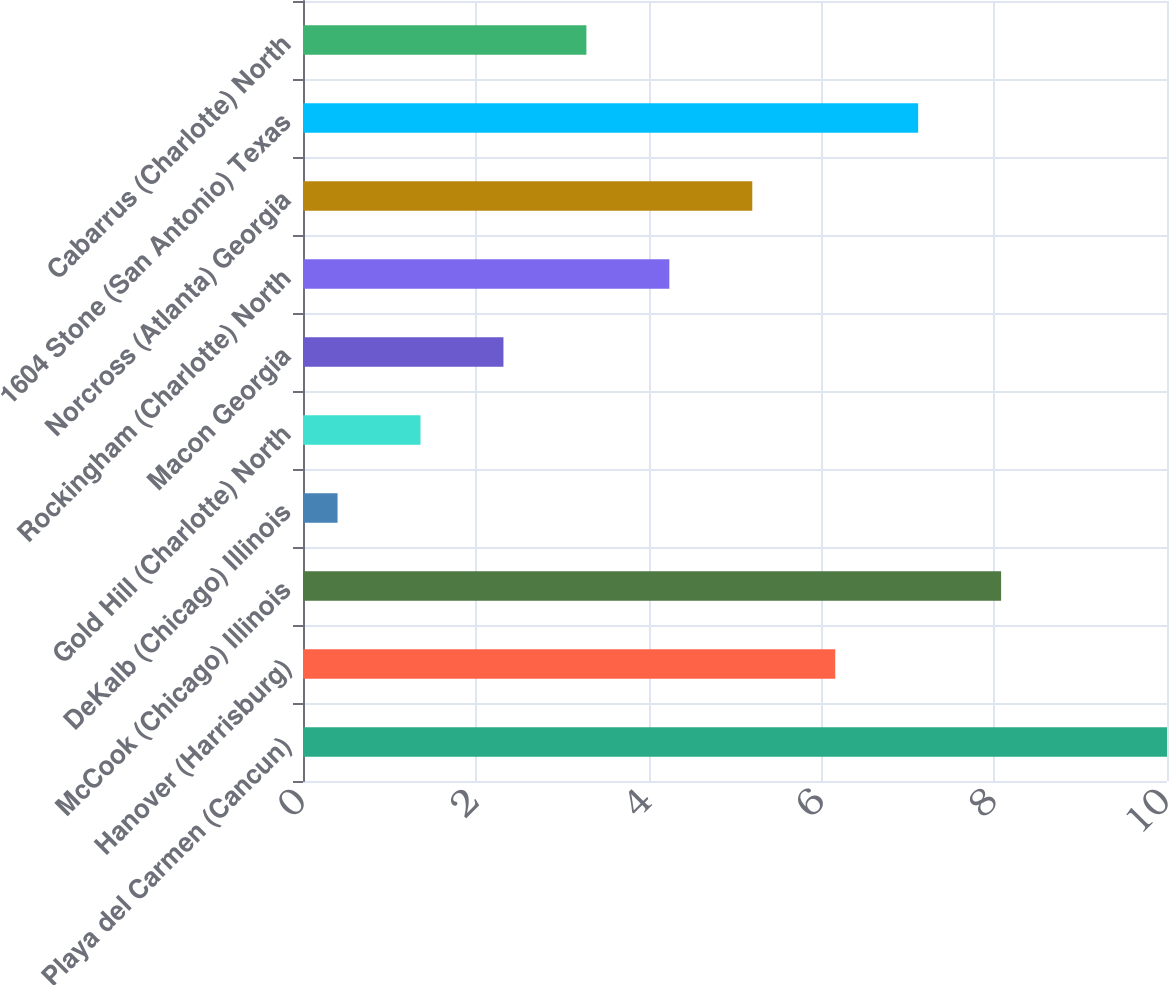Convert chart to OTSL. <chart><loc_0><loc_0><loc_500><loc_500><bar_chart><fcel>Playa del Carmen (Cancun)<fcel>Hanover (Harrisburg)<fcel>McCook (Chicago) Illinois<fcel>DeKalb (Chicago) Illinois<fcel>Gold Hill (Charlotte) North<fcel>Macon Georgia<fcel>Rockingham (Charlotte) North<fcel>Norcross (Atlanta) Georgia<fcel>1604 Stone (San Antonio) Texas<fcel>Cabarrus (Charlotte) North<nl><fcel>10<fcel>6.16<fcel>8.08<fcel>0.4<fcel>1.36<fcel>2.32<fcel>4.24<fcel>5.2<fcel>7.12<fcel>3.28<nl></chart> 